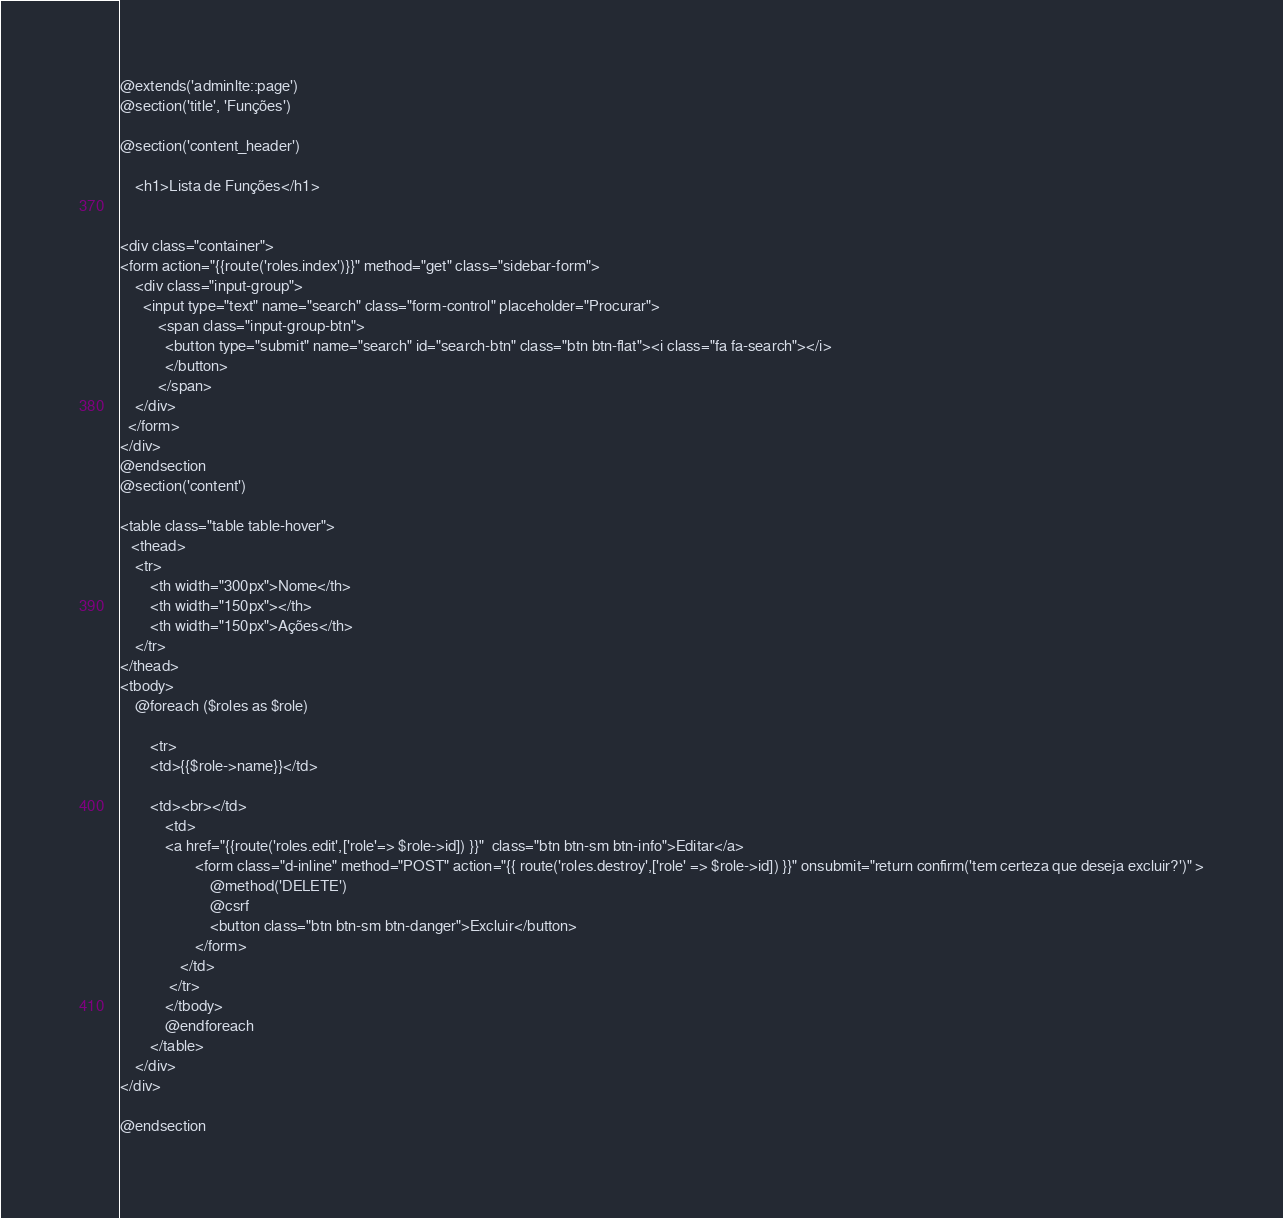Convert code to text. <code><loc_0><loc_0><loc_500><loc_500><_PHP_>
@extends('adminlte::page')
@section('title', 'Funções')

@section('content_header')

    <h1>Lista de Funções</h1>


<div class="container">
<form action="{{route('roles.index')}}" method="get" class="sidebar-form">
    <div class="input-group">
      <input type="text" name="search" class="form-control" placeholder="Procurar">
          <span class="input-group-btn">
            <button type="submit" name="search" id="search-btn" class="btn btn-flat"><i class="fa fa-search"></i>
            </button>
          </span>
    </div>
  </form>
</div>
@endsection
@section('content')

<table class="table table-hover">
   <thead>
    <tr>
        <th width="300px">Nome</th>
        <th width="150px"></th>
        <th width="150px">Ações</th>
    </tr>
</thead>
<tbody>
    @foreach ($roles as $role)

        <tr>
        <td>{{$role->name}}</td>

        <td><br></td>
            <td>
            <a href="{{route('roles.edit',['role'=> $role->id]) }}"  class="btn btn-sm btn-info">Editar</a>
                    <form class="d-inline" method="POST" action="{{ route('roles.destroy',['role' => $role->id]) }}" onsubmit="return confirm('tem certeza que deseja excluir?')" >
                        @method('DELETE')
                        @csrf
                        <button class="btn btn-sm btn-danger">Excluir</button>
                    </form>
                </td>
             </tr>
            </tbody>
            @endforeach
        </table>
    </div>
</div>

@endsection
</code> 